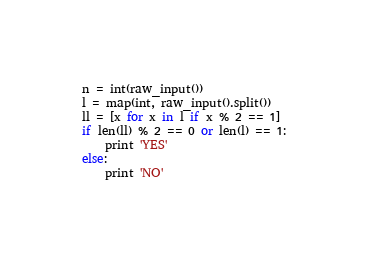Convert code to text. <code><loc_0><loc_0><loc_500><loc_500><_Python_>n = int(raw_input())
l = map(int, raw_input().split())
ll = [x for x in l if x % 2 == 1]
if len(ll) % 2 == 0 or len(l) == 1:
    print 'YES'
else:
    print 'NO'
</code> 